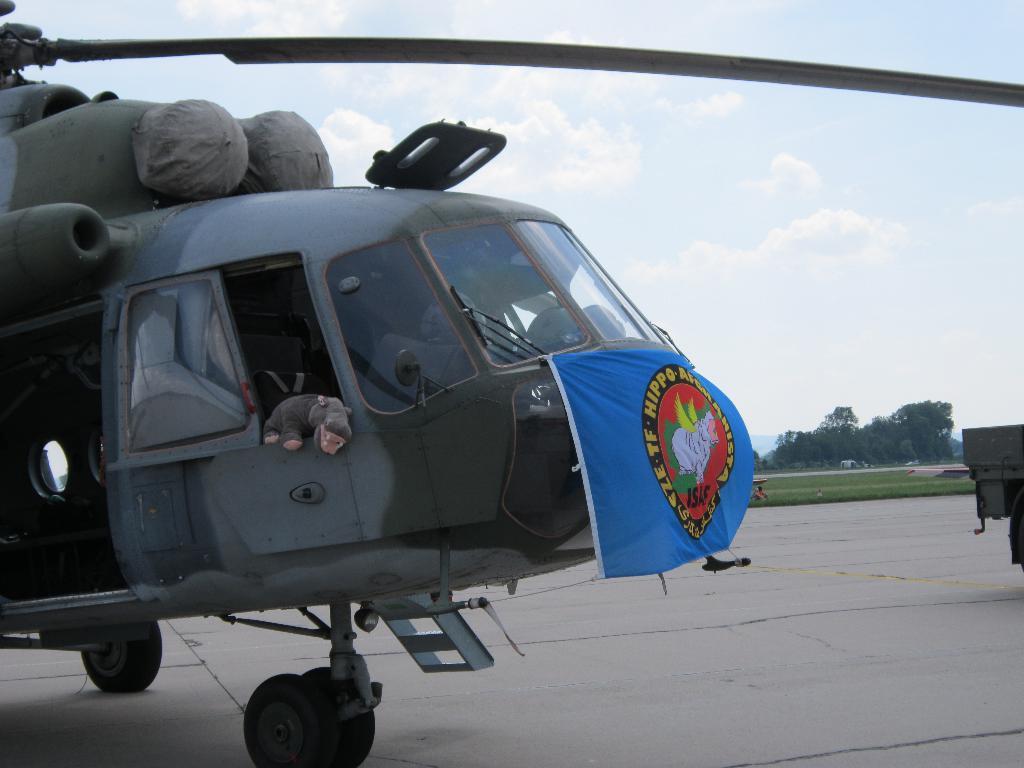Please provide a concise description of this image. This image is taken outdoors. At the bottom of the image there is a floor. At the top of the image there is the sky with clouds. In the background there are a few trees and plants on the ground. On the right side of the image there is a vehicle. On the left side of the image there is a chopper on the floor. 